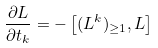<formula> <loc_0><loc_0><loc_500><loc_500>\frac { \partial L } { \partial t _ { k } } = - \left [ ( L ^ { k } ) _ { \geq 1 } , L \right ]</formula> 